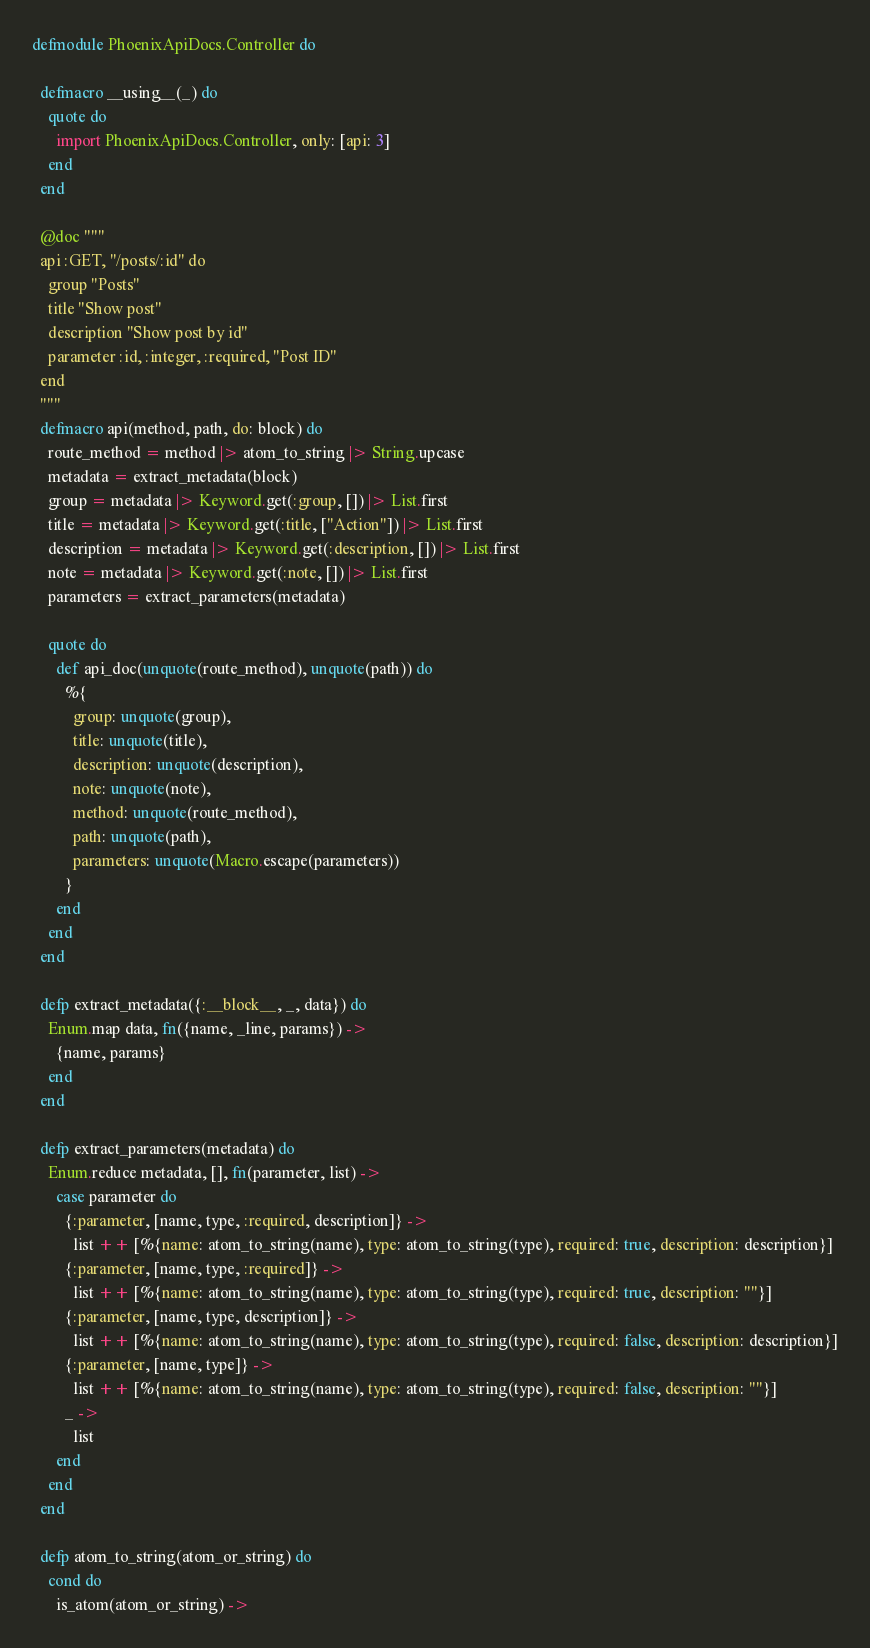<code> <loc_0><loc_0><loc_500><loc_500><_Elixir_>defmodule PhoenixApiDocs.Controller do

  defmacro __using__(_) do
    quote do
      import PhoenixApiDocs.Controller, only: [api: 3]
    end
  end

  @doc """
  api :GET, "/posts/:id" do
    group "Posts"
    title "Show post"
    description "Show post by id"
    parameter :id, :integer, :required, "Post ID"
  end
  """
  defmacro api(method, path, do: block) do
    route_method = method |> atom_to_string |> String.upcase
    metadata = extract_metadata(block)
    group = metadata |> Keyword.get(:group, []) |> List.first
    title = metadata |> Keyword.get(:title, ["Action"]) |> List.first
    description = metadata |> Keyword.get(:description, []) |> List.first
    note = metadata |> Keyword.get(:note, []) |> List.first
    parameters = extract_parameters(metadata)

    quote do
      def api_doc(unquote(route_method), unquote(path)) do
        %{
          group: unquote(group),
          title: unquote(title),
          description: unquote(description),
          note: unquote(note),
          method: unquote(route_method),
          path: unquote(path),
          parameters: unquote(Macro.escape(parameters))
        }
      end
    end
  end

  defp extract_metadata({:__block__, _, data}) do
    Enum.map data, fn({name, _line, params}) ->
      {name, params}
    end
  end

  defp extract_parameters(metadata) do
    Enum.reduce metadata, [], fn(parameter, list) ->
      case parameter do
        {:parameter, [name, type, :required, description]} ->
          list ++ [%{name: atom_to_string(name), type: atom_to_string(type), required: true, description: description}]
        {:parameter, [name, type, :required]} ->
          list ++ [%{name: atom_to_string(name), type: atom_to_string(type), required: true, description: ""}]
        {:parameter, [name, type, description]} ->
          list ++ [%{name: atom_to_string(name), type: atom_to_string(type), required: false, description: description}]
        {:parameter, [name, type]} ->
          list ++ [%{name: atom_to_string(name), type: atom_to_string(type), required: false, description: ""}]
        _ ->
          list
      end
    end
  end

  defp atom_to_string(atom_or_string) do
    cond do
      is_atom(atom_or_string) -></code> 